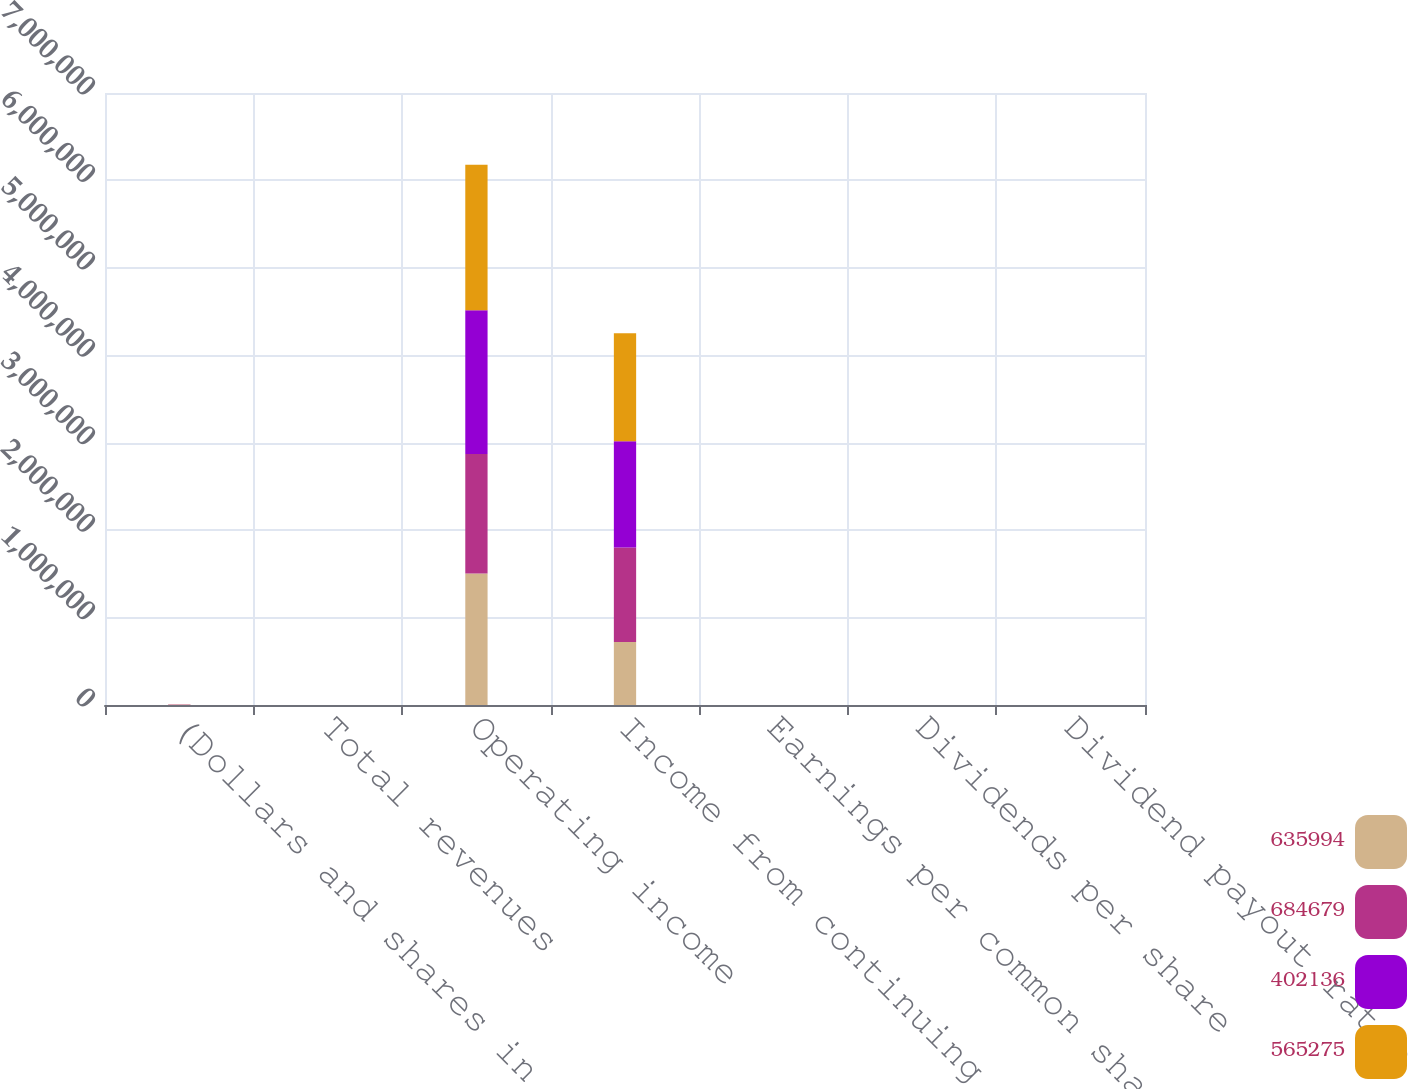<chart> <loc_0><loc_0><loc_500><loc_500><stacked_bar_chart><ecel><fcel>(Dollars and shares in<fcel>Total revenues<fcel>Operating income<fcel>Income from continuing<fcel>Earnings per common share from<fcel>Dividends per share<fcel>Dividend payout ratio (2)<nl><fcel>635994<fcel>2017<fcel>53.55<fcel>1.50309e+06<fcel>721209<fcel>1.79<fcel>1.72<fcel>96.2<nl><fcel>684679<fcel>2016<fcel>53.55<fcel>1.36826e+06<fcel>1.07885e+06<fcel>2.56<fcel>1.53<fcel>59.9<nl><fcel>402136<fcel>2015<fcel>53.55<fcel>1.64483e+06<fcel>1.21706e+06<fcel>2.82<fcel>1.33<fcel>47.2<nl><fcel>565275<fcel>2014<fcel>53.55<fcel>1.66339e+06<fcel>1.23371e+06<fcel>2.8<fcel>1.11<fcel>39.5<nl></chart> 